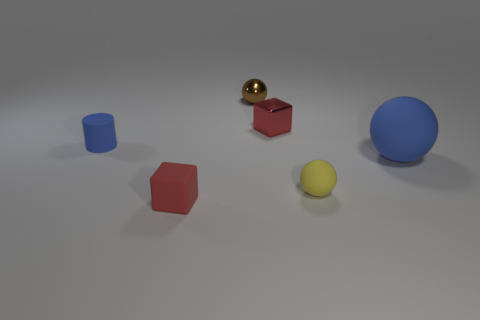Subtract all red blocks. How many were subtracted if there are1red blocks left? 1 Add 3 yellow things. How many objects exist? 9 Subtract all blocks. How many objects are left? 4 Subtract 0 purple cubes. How many objects are left? 6 Subtract all tiny gray matte balls. Subtract all tiny rubber objects. How many objects are left? 3 Add 3 tiny brown balls. How many tiny brown balls are left? 4 Add 2 tiny brown metallic cubes. How many tiny brown metallic cubes exist? 2 